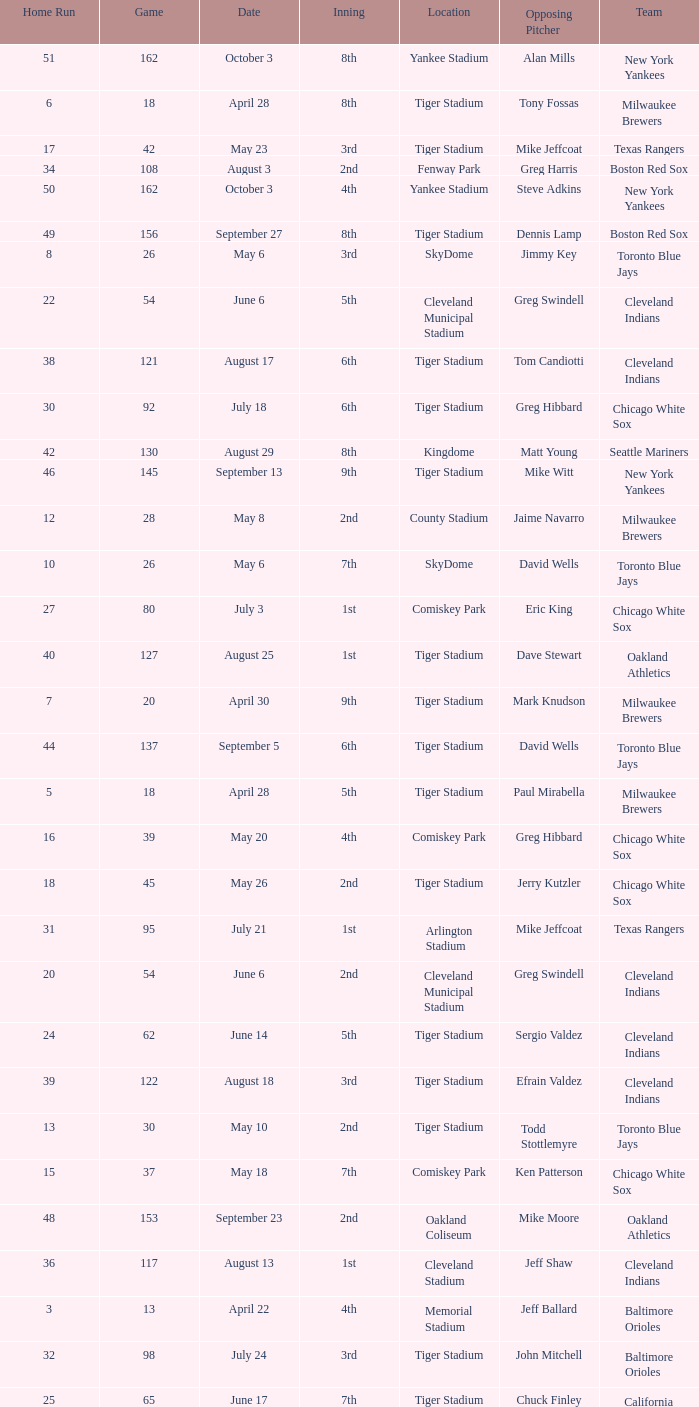Would you be able to parse every entry in this table? {'header': ['Home Run', 'Game', 'Date', 'Inning', 'Location', 'Opposing Pitcher', 'Team'], 'rows': [['51', '162', 'October 3', '8th', 'Yankee Stadium', 'Alan Mills', 'New York Yankees'], ['6', '18', 'April 28', '8th', 'Tiger Stadium', 'Tony Fossas', 'Milwaukee Brewers'], ['17', '42', 'May 23', '3rd', 'Tiger Stadium', 'Mike Jeffcoat', 'Texas Rangers'], ['34', '108', 'August 3', '2nd', 'Fenway Park', 'Greg Harris', 'Boston Red Sox'], ['50', '162', 'October 3', '4th', 'Yankee Stadium', 'Steve Adkins', 'New York Yankees'], ['49', '156', 'September 27', '8th', 'Tiger Stadium', 'Dennis Lamp', 'Boston Red Sox'], ['8', '26', 'May 6', '3rd', 'SkyDome', 'Jimmy Key', 'Toronto Blue Jays'], ['22', '54', 'June 6', '5th', 'Cleveland Municipal Stadium', 'Greg Swindell', 'Cleveland Indians'], ['38', '121', 'August 17', '6th', 'Tiger Stadium', 'Tom Candiotti', 'Cleveland Indians'], ['30', '92', 'July 18', '6th', 'Tiger Stadium', 'Greg Hibbard', 'Chicago White Sox'], ['42', '130', 'August 29', '8th', 'Kingdome', 'Matt Young', 'Seattle Mariners'], ['46', '145', 'September 13', '9th', 'Tiger Stadium', 'Mike Witt', 'New York Yankees'], ['12', '28', 'May 8', '2nd', 'County Stadium', 'Jaime Navarro', 'Milwaukee Brewers'], ['10', '26', 'May 6', '7th', 'SkyDome', 'David Wells', 'Toronto Blue Jays'], ['27', '80', 'July 3', '1st', 'Comiskey Park', 'Eric King', 'Chicago White Sox'], ['40', '127', 'August 25', '1st', 'Tiger Stadium', 'Dave Stewart', 'Oakland Athletics'], ['7', '20', 'April 30', '9th', 'Tiger Stadium', 'Mark Knudson', 'Milwaukee Brewers'], ['44', '137', 'September 5', '6th', 'Tiger Stadium', 'David Wells', 'Toronto Blue Jays'], ['5', '18', 'April 28', '5th', 'Tiger Stadium', 'Paul Mirabella', 'Milwaukee Brewers'], ['16', '39', 'May 20', '4th', 'Comiskey Park', 'Greg Hibbard', 'Chicago White Sox'], ['18', '45', 'May 26', '2nd', 'Tiger Stadium', 'Jerry Kutzler', 'Chicago White Sox'], ['31', '95', 'July 21', '1st', 'Arlington Stadium', 'Mike Jeffcoat', 'Texas Rangers'], ['20', '54', 'June 6', '2nd', 'Cleveland Municipal Stadium', 'Greg Swindell', 'Cleveland Indians'], ['24', '62', 'June 14', '5th', 'Tiger Stadium', 'Sergio Valdez', 'Cleveland Indians'], ['39', '122', 'August 18', '3rd', 'Tiger Stadium', 'Efrain Valdez', 'Cleveland Indians'], ['13', '30', 'May 10', '2nd', 'Tiger Stadium', 'Todd Stottlemyre', 'Toronto Blue Jays'], ['15', '37', 'May 18', '7th', 'Comiskey Park', 'Ken Patterson', 'Chicago White Sox'], ['48', '153', 'September 23', '2nd', 'Oakland Coliseum', 'Mike Moore', 'Oakland Athletics'], ['36', '117', 'August 13', '1st', 'Cleveland Stadium', 'Jeff Shaw', 'Cleveland Indians'], ['3', '13', 'April 22', '4th', 'Memorial Stadium', 'Jeff Ballard', 'Baltimore Orioles'], ['32', '98', 'July 24', '3rd', 'Tiger Stadium', 'John Mitchell', 'Baltimore Orioles'], ['25', '65', 'June 17', '7th', 'Tiger Stadium', 'Chuck Finley', 'California Angels'], ['37', '120', 'August 16', '3rd', 'Tiger Stadium', 'Ron Robinson', 'Milwaukee Brewers'], ['21', '54', 'June 6', '4th', 'Cleveland Municipal Stadium', 'Greg Swindell', 'Cleveland Indians'], ['28', '83', 'July 6', '4th', 'Tiger Stadium', 'Tom Gordon', 'Kansas City Royals'], ['2', '9', 'April 18', '5th', 'Tiger Stadium', 'Clay Parker', 'New York Yankees'], ['4', '15', 'April 24', '9th', 'Metrodome', 'John Candelaria', 'Minnesota Twins'], ['23', '61', 'June 13', '2nd', 'Tiger Stadium', 'John Farrell', 'Cleveland Indians'], ['47', '148', 'September 16', '5th', 'Tiger Stadium', 'Mark Leiter', 'New York Yankees'], ['33', '104', 'July 30', '4th', 'Yankee Stadium', 'Dave LaPoint', 'New York Yankees'], ['43', '135', 'September 3', '6th', 'Tiger Stadium', 'Jimmy Key', 'Toronto Blue Jays'], ['19', '50', 'June 1', '2nd', 'Kingdome', 'Matt Young', 'Seattle Mariners'], ['45', '139', 'September 7', '6th', 'County Stadium', 'Ted Higuera', 'Milwaukee Brewers'], ['41', '127', 'August 25', '4th', 'Tiger Stadium', 'Dave Stewart', 'Oakland Athletics'], ['1', '6', 'April 14', '6th', 'Tiger Stadium', 'Dave Johnson', 'Baltimore Orioles'], ['26', '77', 'June 30', '5th', 'Royals Stadium', 'Storm Davis', 'Kansas City Royals'], ['9', '26', 'May 6', '5th', 'SkyDome', 'Jimmy Key', 'Toronto Blue Jays'], ['11', '27', 'May 7', '4th', 'County Stadium', 'Mark Knudson', 'Milwaukee Brewers'], ['29', '87', 'July 13', '6th', 'Tiger Stadium', 'Bobby Witt', 'Texas Rangers'], ['14', '34', 'May 15', '7th', 'Arlington Stadium', 'Kevin Brown', 'Texas Rangers'], ['35', '111', 'August 7', '9th', 'Skydome', 'Jimmy Key', 'Toronto Blue Jays']]} On june 17, at tiger stadium, what was the mean of home runs? 25.0. 